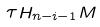<formula> <loc_0><loc_0><loc_500><loc_500>\tau H _ { n - i - 1 } M</formula> 